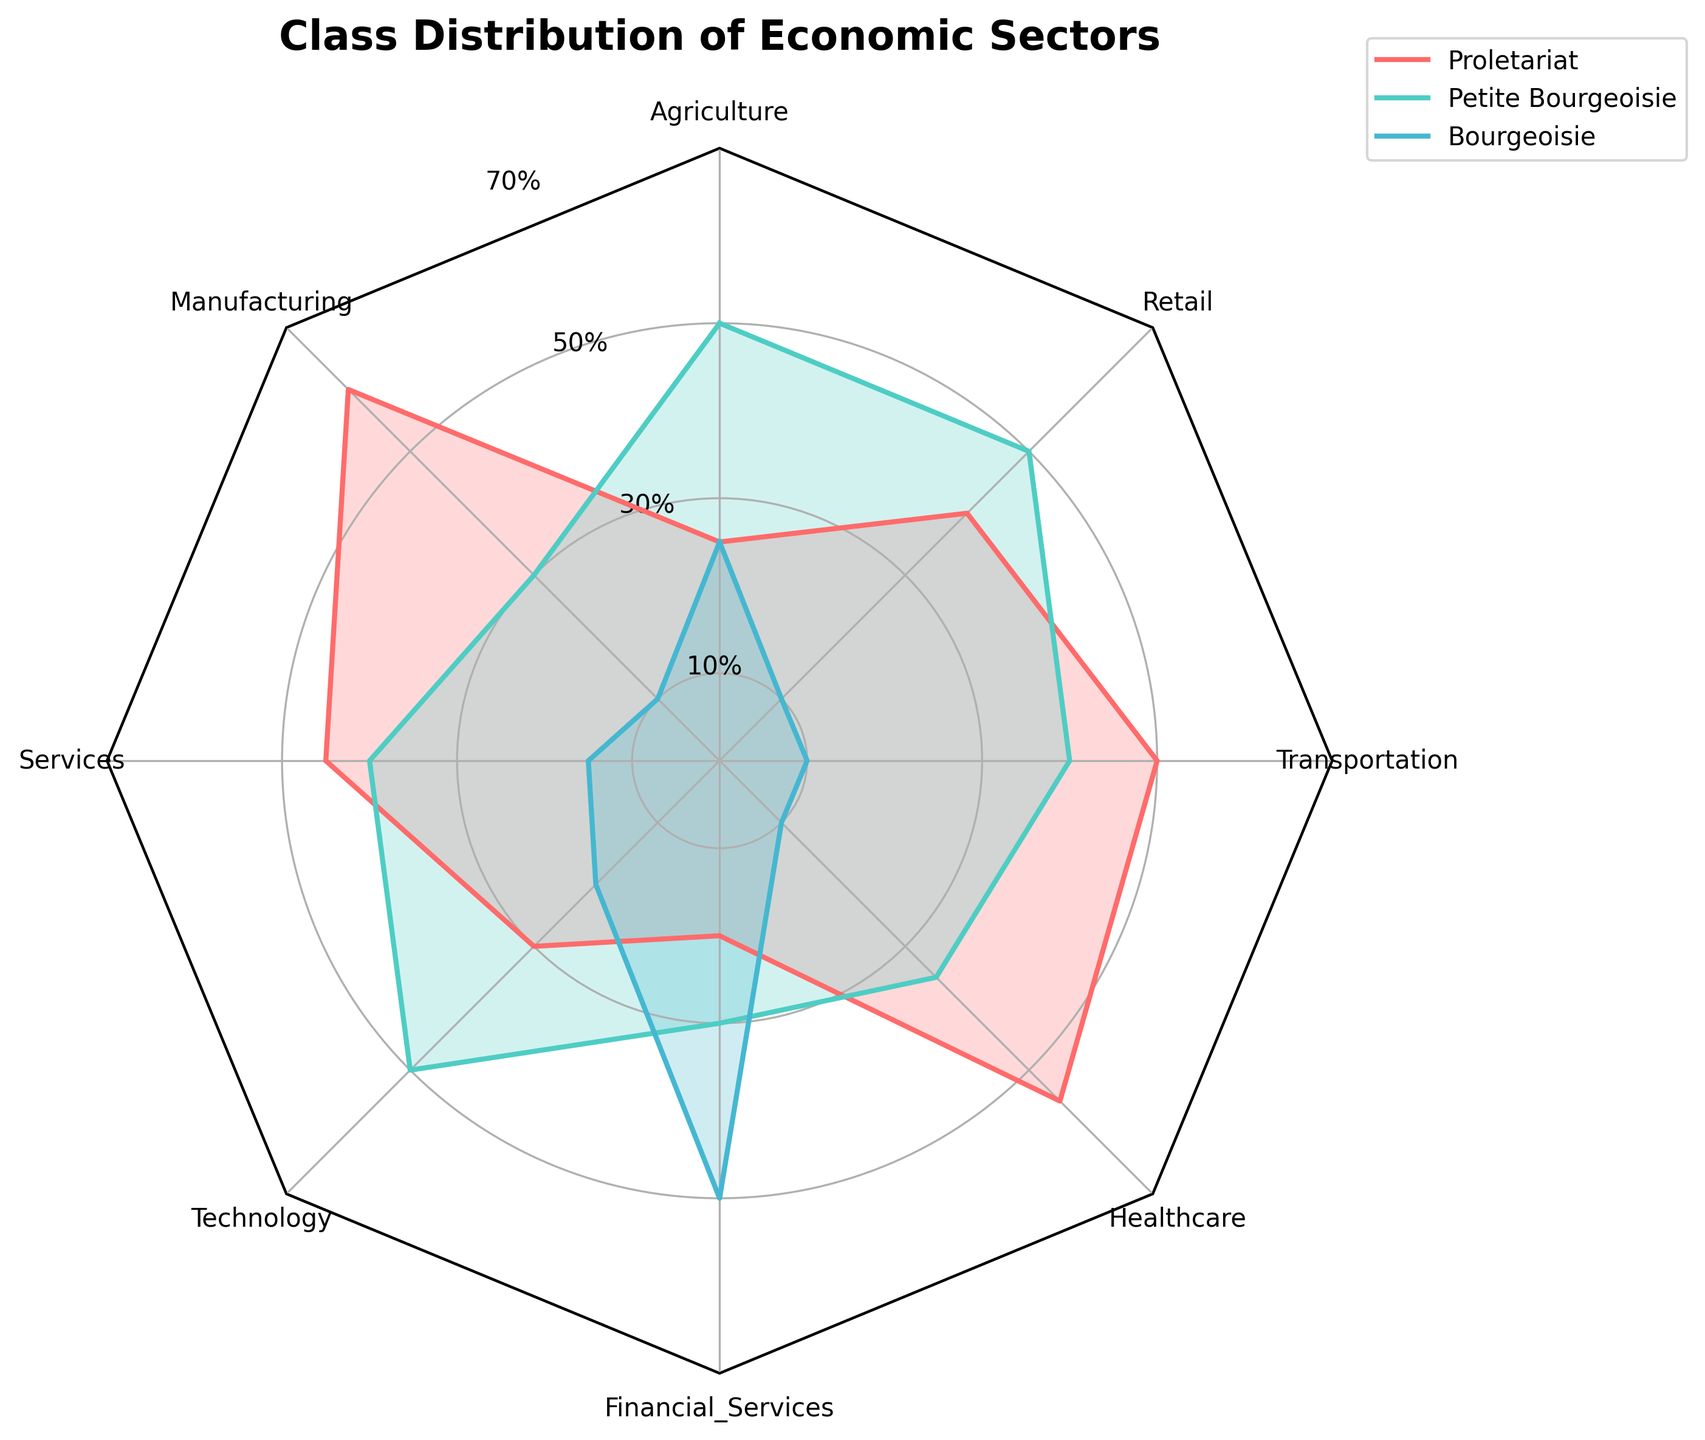What's the title of the radar chart? The title is located at the top of the radar chart, indicating what the figure represents.
Answer: Class Distribution of Economic Sectors What does the legend in the top-right corner indicate? The legend explains the color coding of the lines and filled areas, representing different classes.
Answer: Proletariat, Petite Bourgeoisie, Bourgeoisie Which sector has the highest proportion of the Bourgeoisie? By looking at the peak values for the Bourgeoisie in the radar chart, Financial Services has the highest proportion.
Answer: Financial Services Which class has the lowest representation in Technology? By comparing the values for Technology across all three classes, the Bourgeoisie class has the lowest representation.
Answer: Bourgeoisie What is the range of percentage values represented on the y-axis? The y-axis labels range from 0% to 70%, as shown by the ticks and their labels.
Answer: 0% to 70% What sectors have an even distribution across all three classes? Sectors like Technology and Retail have closer values across Proletariat, Petite Bourgeoisie, and Bourgeoisie, visible by the similar lengths of their vertices.
Answer: Agriculture Which class has the largest variation in their sector percentages? By examining the spread of each class across different economic sectors, the Proletariat shows the largest variation from 20% to 60%.
Answer: Proletariat In which sector do the Petite Bourgeoisie and the Bourgeoisie have nearly equal representation? The values for Petite Bourgeoisie and Bourgeoisie are closest in Agriculture.
Answer: Agriculture Comparing Healthcare and Manufacturing, which class is more represented in Healthcare but less in Manufacturing? By comparing values for Proletariat, Petite Bourgeoisie, and Bourgeoisie in both sectors, Proletariat is more represented in Healthcare and less in Manufacturing.
Answer: Proletariat What is the average proportion of the Proletariat class across all sectors? Calculate the average: (25 + 60 + 45 + 30 + 20 + 55 + 50 + 40) / 8 = 40.625
Answer: 40.625 